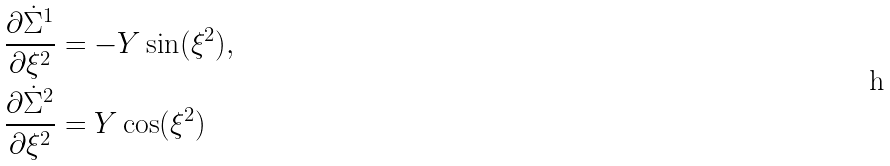<formula> <loc_0><loc_0><loc_500><loc_500>& \frac { \partial \dot { \Sigma } ^ { 1 } } { \partial \xi ^ { 2 } } = - Y \sin ( \xi ^ { 2 } ) , \\ & \frac { \partial \dot { \Sigma } ^ { 2 } } { \partial \xi ^ { 2 } } = Y \cos ( \xi ^ { 2 } )</formula> 